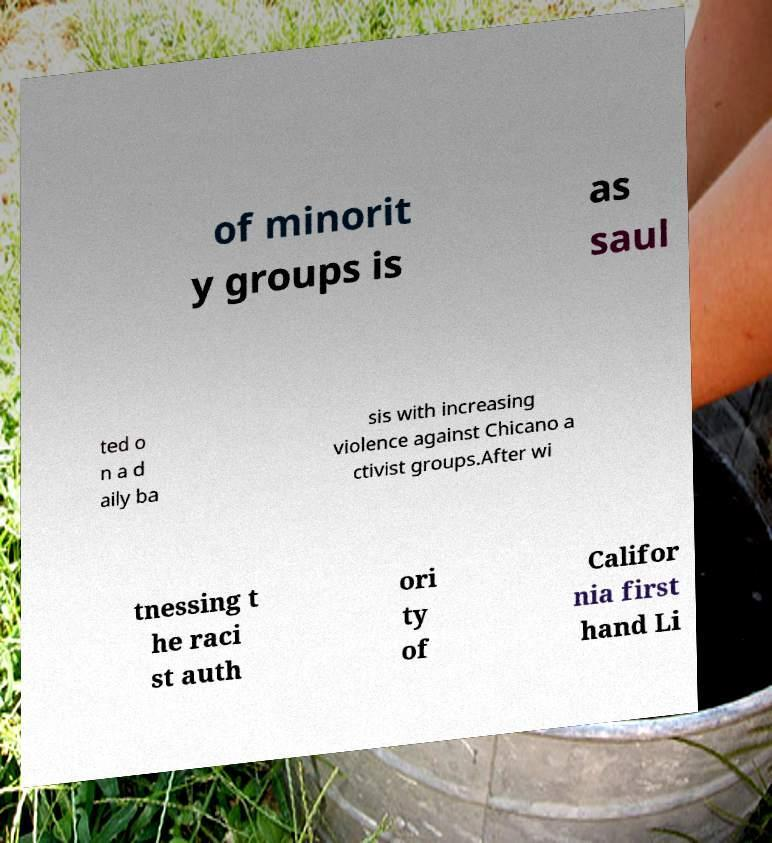Can you accurately transcribe the text from the provided image for me? of minorit y groups is as saul ted o n a d aily ba sis with increasing violence against Chicano a ctivist groups.After wi tnessing t he raci st auth ori ty of Califor nia first hand Li 